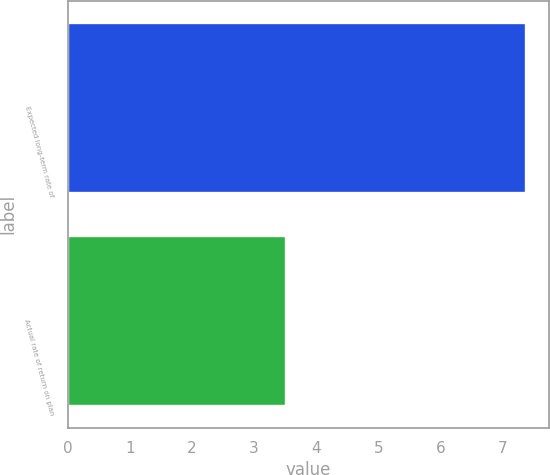Convert chart to OTSL. <chart><loc_0><loc_0><loc_500><loc_500><bar_chart><fcel>Expected long-term rate of<fcel>Actual rate of return on plan<nl><fcel>7.38<fcel>3.51<nl></chart> 